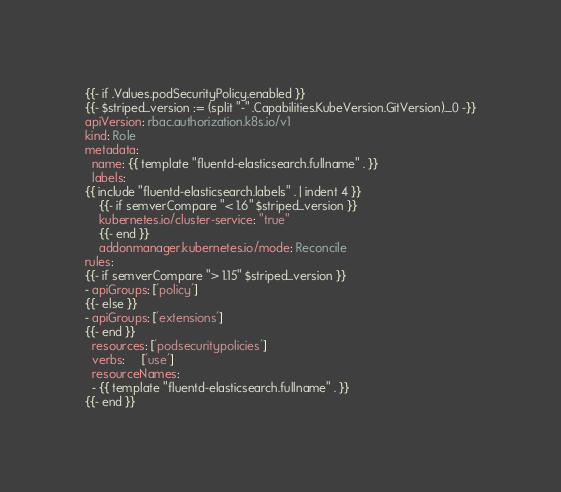Convert code to text. <code><loc_0><loc_0><loc_500><loc_500><_YAML_>{{- if .Values.podSecurityPolicy.enabled }}
{{- $striped_version := (split "-" .Capabilities.KubeVersion.GitVersion)._0 -}}
apiVersion: rbac.authorization.k8s.io/v1
kind: Role
metadata:
  name: {{ template "fluentd-elasticsearch.fullname" . }}
  labels:
{{ include "fluentd-elasticsearch.labels" . | indent 4 }}
    {{- if semverCompare "< 1.6" $striped_version }}
    kubernetes.io/cluster-service: "true"
    {{- end }}
    addonmanager.kubernetes.io/mode: Reconcile
rules:
{{- if semverCompare "> 1.15" $striped_version }}
- apiGroups: ['policy']
{{- else }}
- apiGroups: ['extensions']
{{- end }}
  resources: ['podsecuritypolicies']
  verbs:     ['use']
  resourceNames:
  - {{ template "fluentd-elasticsearch.fullname" . }}
{{- end }}
</code> 